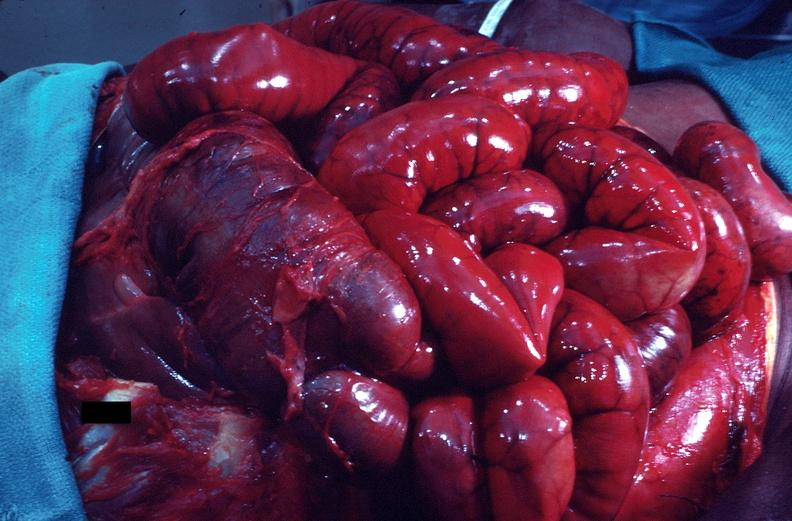where does this belong to?
Answer the question using a single word or phrase. Gastrointestinal system 